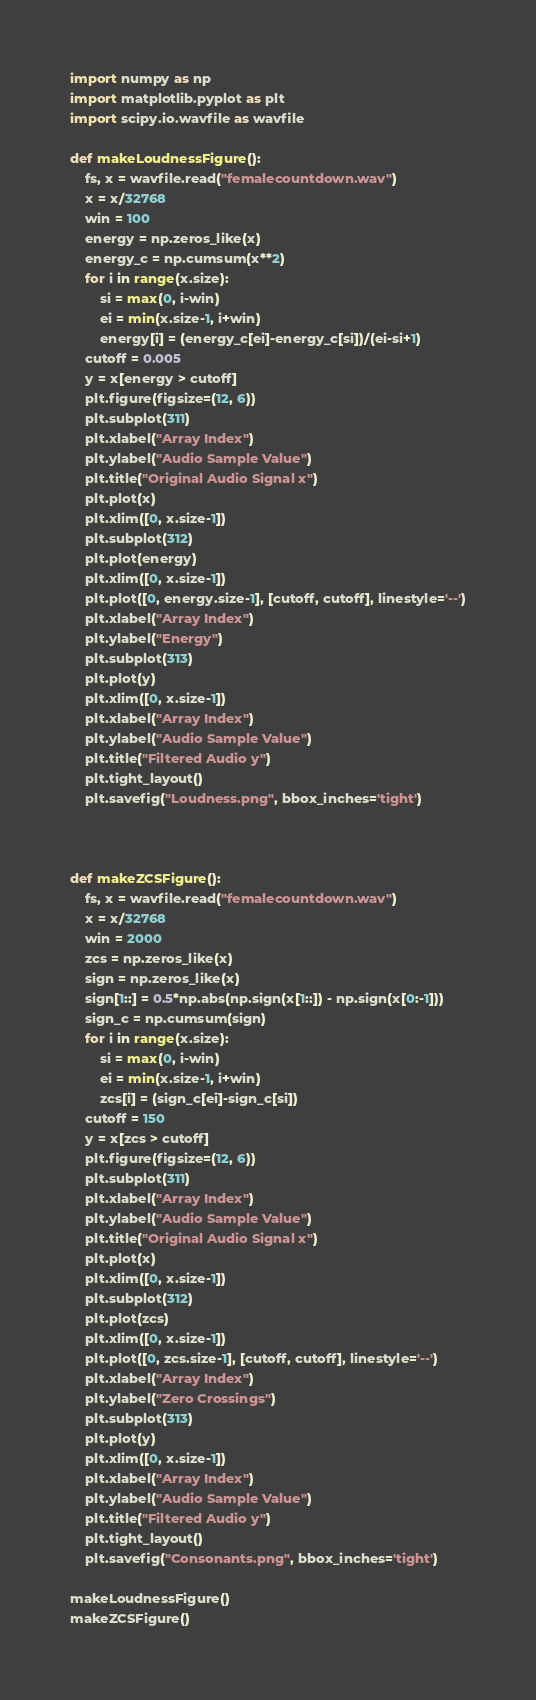Convert code to text. <code><loc_0><loc_0><loc_500><loc_500><_Python_>import numpy as np
import matplotlib.pyplot as plt
import scipy.io.wavfile as wavfile

def makeLoudnessFigure():
    fs, x = wavfile.read("femalecountdown.wav")
    x = x/32768
    win = 100
    energy = np.zeros_like(x)
    energy_c = np.cumsum(x**2)
    for i in range(x.size):
        si = max(0, i-win)
        ei = min(x.size-1, i+win)
        energy[i] = (energy_c[ei]-energy_c[si])/(ei-si+1)
    cutoff = 0.005
    y = x[energy > cutoff]
    plt.figure(figsize=(12, 6))
    plt.subplot(311)
    plt.xlabel("Array Index")
    plt.ylabel("Audio Sample Value")
    plt.title("Original Audio Signal x")
    plt.plot(x)
    plt.xlim([0, x.size-1])
    plt.subplot(312)
    plt.plot(energy)
    plt.xlim([0, x.size-1])
    plt.plot([0, energy.size-1], [cutoff, cutoff], linestyle='--')
    plt.xlabel("Array Index")
    plt.ylabel("Energy")
    plt.subplot(313)
    plt.plot(y)
    plt.xlim([0, x.size-1])
    plt.xlabel("Array Index")
    plt.ylabel("Audio Sample Value")
    plt.title("Filtered Audio y")
    plt.tight_layout()
    plt.savefig("Loudness.png", bbox_inches='tight')



def makeZCSFigure():
    fs, x = wavfile.read("femalecountdown.wav")
    x = x/32768
    win = 2000
    zcs = np.zeros_like(x)
    sign = np.zeros_like(x)
    sign[1::] = 0.5*np.abs(np.sign(x[1::]) - np.sign(x[0:-1]))
    sign_c = np.cumsum(sign)
    for i in range(x.size):
        si = max(0, i-win)
        ei = min(x.size-1, i+win)
        zcs[i] = (sign_c[ei]-sign_c[si])
    cutoff = 150
    y = x[zcs > cutoff]
    plt.figure(figsize=(12, 6))
    plt.subplot(311)
    plt.xlabel("Array Index")
    plt.ylabel("Audio Sample Value")
    plt.title("Original Audio Signal x")
    plt.plot(x)
    plt.xlim([0, x.size-1])
    plt.subplot(312)
    plt.plot(zcs)
    plt.xlim([0, x.size-1])
    plt.plot([0, zcs.size-1], [cutoff, cutoff], linestyle='--')
    plt.xlabel("Array Index")
    plt.ylabel("Zero Crossings")
    plt.subplot(313)
    plt.plot(y)
    plt.xlim([0, x.size-1])
    plt.xlabel("Array Index")
    plt.ylabel("Audio Sample Value")
    plt.title("Filtered Audio y")
    plt.tight_layout()
    plt.savefig("Consonants.png", bbox_inches='tight')

makeLoudnessFigure()
makeZCSFigure()</code> 